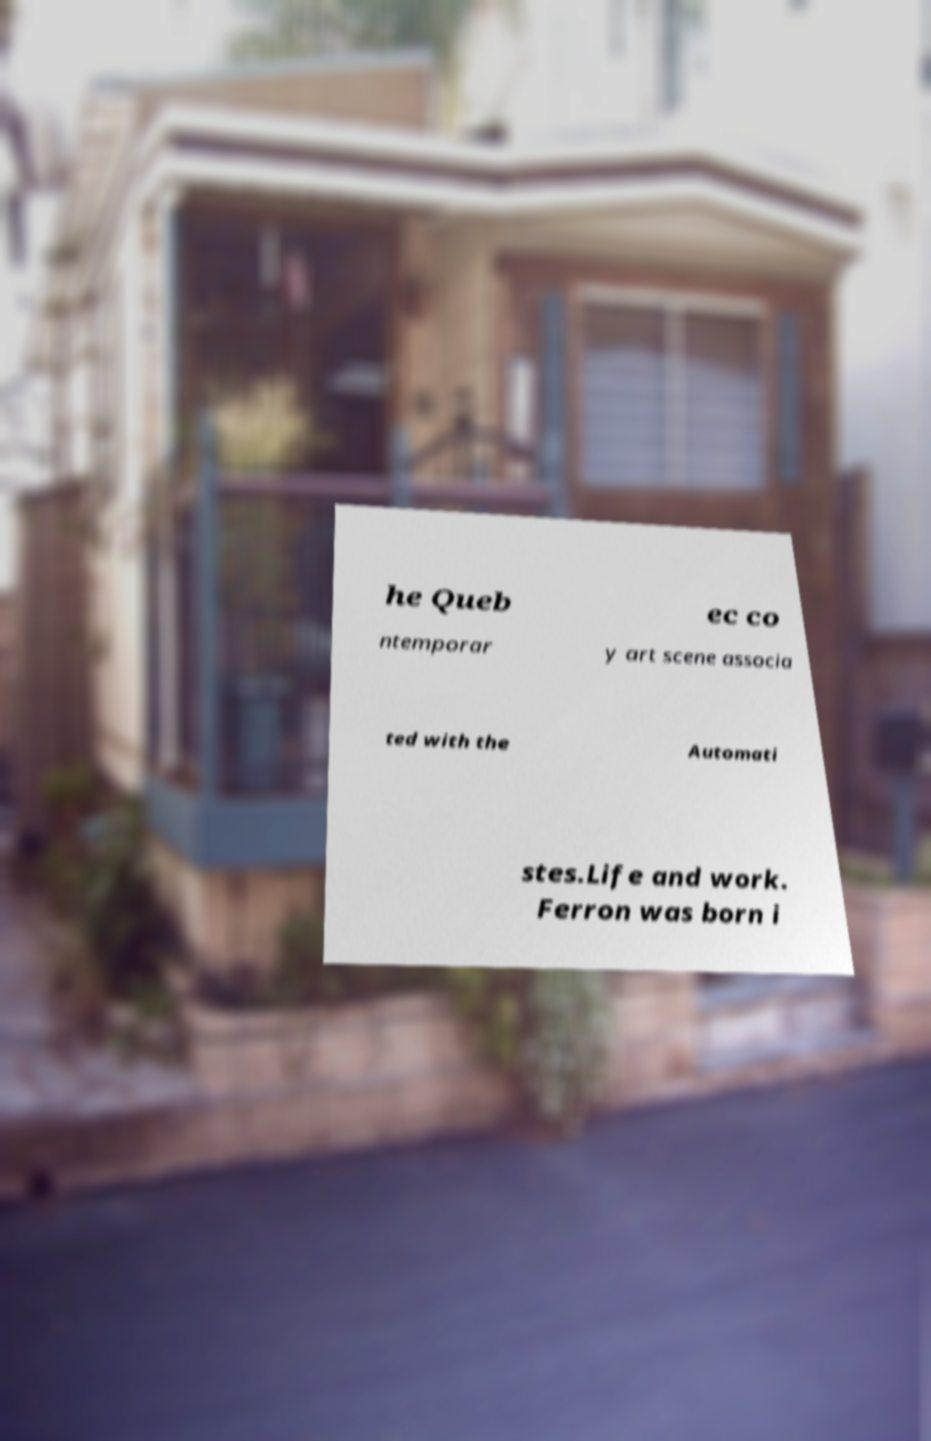I need the written content from this picture converted into text. Can you do that? he Queb ec co ntemporar y art scene associa ted with the Automati stes.Life and work. Ferron was born i 